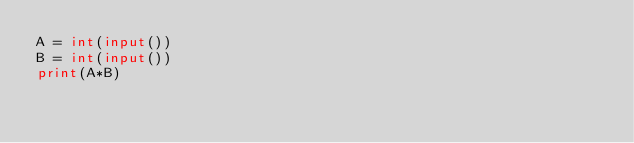Convert code to text. <code><loc_0><loc_0><loc_500><loc_500><_Python_>A = int(input())
B = int(input())
print(A*B)</code> 